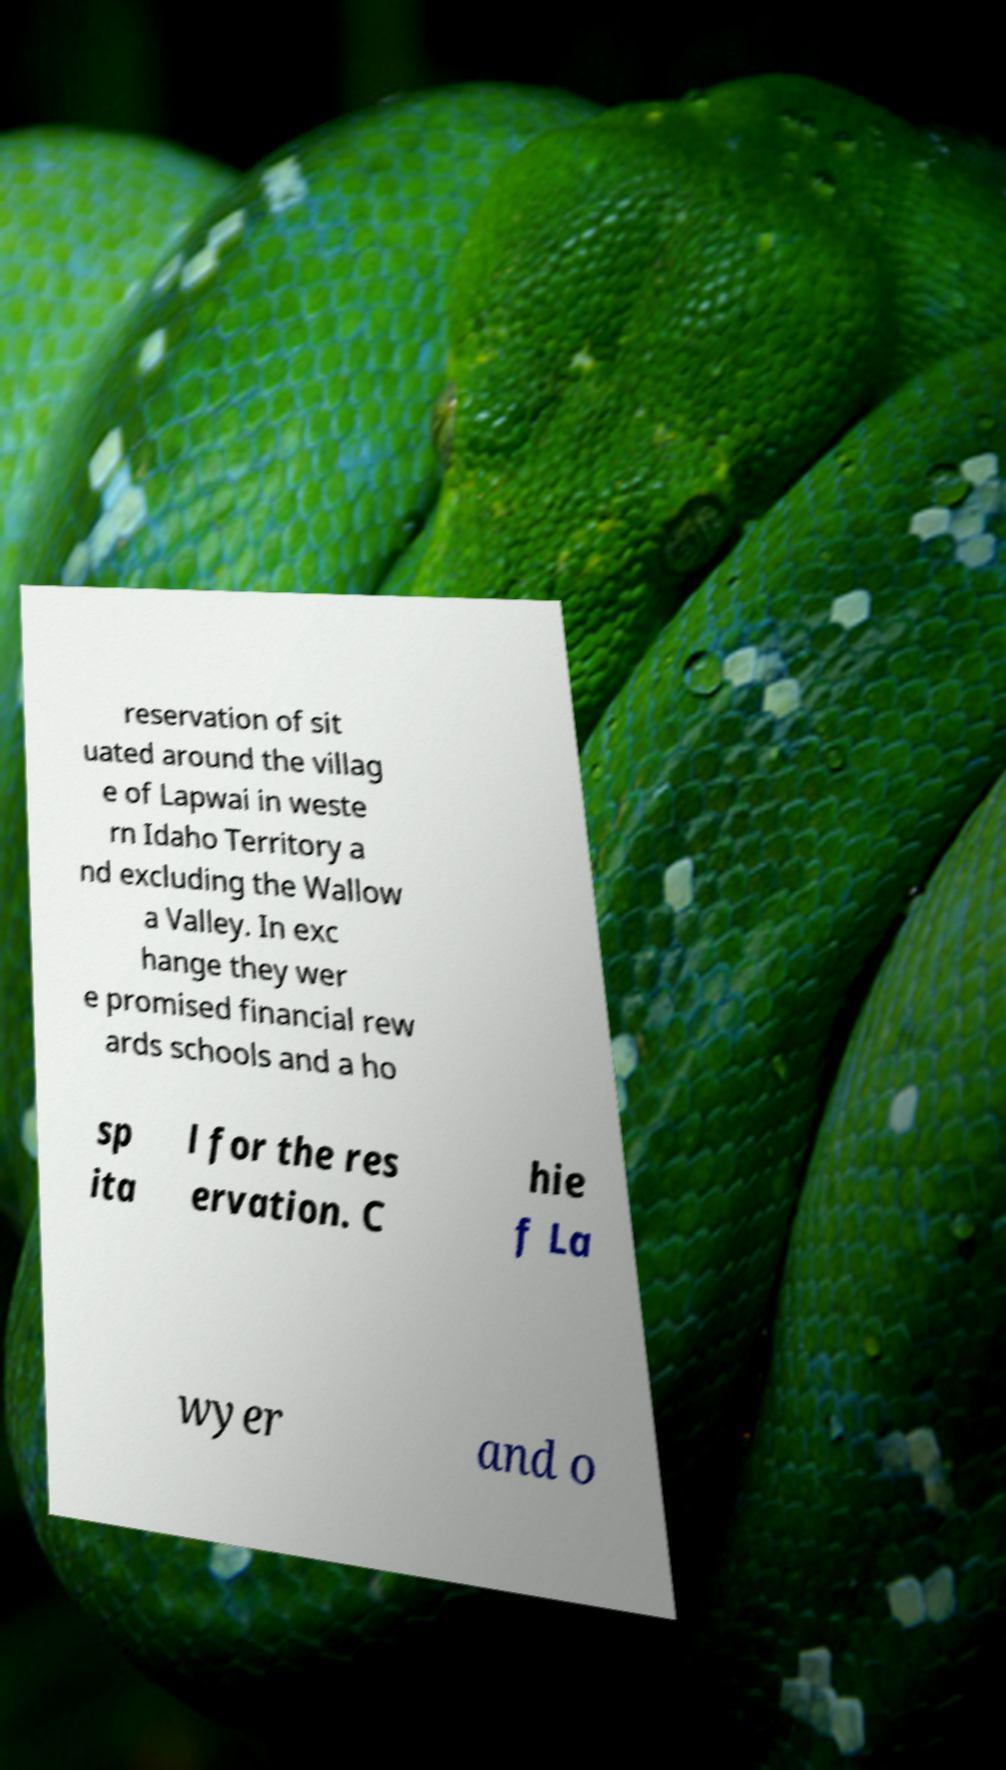Can you accurately transcribe the text from the provided image for me? reservation of sit uated around the villag e of Lapwai in weste rn Idaho Territory a nd excluding the Wallow a Valley. In exc hange they wer e promised financial rew ards schools and a ho sp ita l for the res ervation. C hie f La wyer and o 